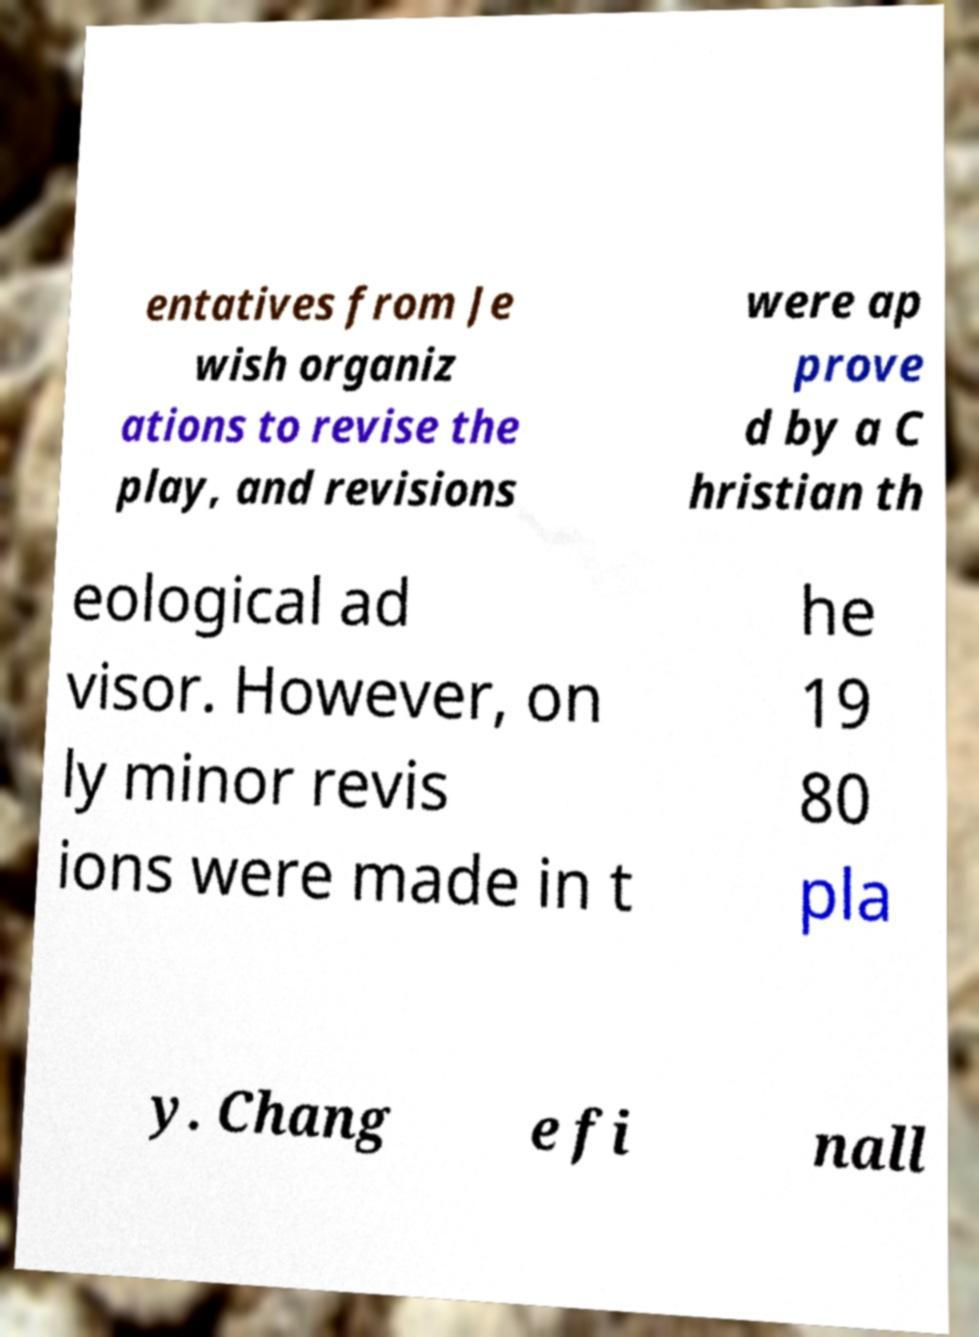I need the written content from this picture converted into text. Can you do that? entatives from Je wish organiz ations to revise the play, and revisions were ap prove d by a C hristian th eological ad visor. However, on ly minor revis ions were made in t he 19 80 pla y. Chang e fi nall 